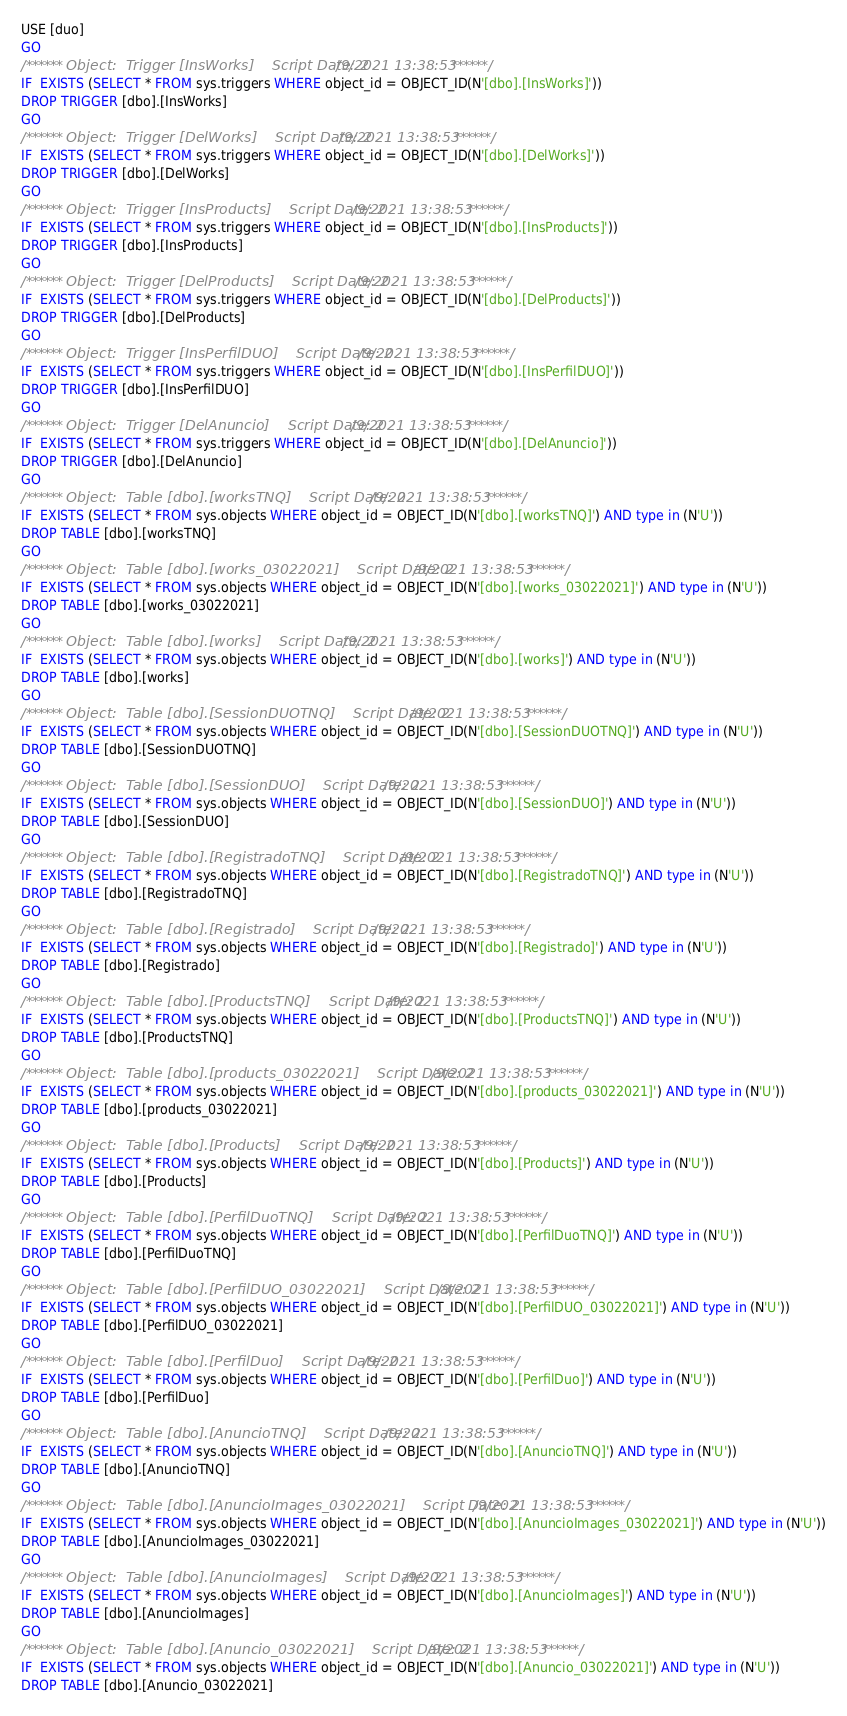Convert code to text. <code><loc_0><loc_0><loc_500><loc_500><_SQL_>USE [duo]
GO
/****** Object:  Trigger [InsWorks]    Script Date: 2/9/2021 13:38:53 ******/
IF  EXISTS (SELECT * FROM sys.triggers WHERE object_id = OBJECT_ID(N'[dbo].[InsWorks]'))
DROP TRIGGER [dbo].[InsWorks]
GO
/****** Object:  Trigger [DelWorks]    Script Date: 2/9/2021 13:38:53 ******/
IF  EXISTS (SELECT * FROM sys.triggers WHERE object_id = OBJECT_ID(N'[dbo].[DelWorks]'))
DROP TRIGGER [dbo].[DelWorks]
GO
/****** Object:  Trigger [InsProducts]    Script Date: 2/9/2021 13:38:53 ******/
IF  EXISTS (SELECT * FROM sys.triggers WHERE object_id = OBJECT_ID(N'[dbo].[InsProducts]'))
DROP TRIGGER [dbo].[InsProducts]
GO
/****** Object:  Trigger [DelProducts]    Script Date: 2/9/2021 13:38:53 ******/
IF  EXISTS (SELECT * FROM sys.triggers WHERE object_id = OBJECT_ID(N'[dbo].[DelProducts]'))
DROP TRIGGER [dbo].[DelProducts]
GO
/****** Object:  Trigger [InsPerfilDUO]    Script Date: 2/9/2021 13:38:53 ******/
IF  EXISTS (SELECT * FROM sys.triggers WHERE object_id = OBJECT_ID(N'[dbo].[InsPerfilDUO]'))
DROP TRIGGER [dbo].[InsPerfilDUO]
GO
/****** Object:  Trigger [DelAnuncio]    Script Date: 2/9/2021 13:38:53 ******/
IF  EXISTS (SELECT * FROM sys.triggers WHERE object_id = OBJECT_ID(N'[dbo].[DelAnuncio]'))
DROP TRIGGER [dbo].[DelAnuncio]
GO
/****** Object:  Table [dbo].[worksTNQ]    Script Date: 2/9/2021 13:38:53 ******/
IF  EXISTS (SELECT * FROM sys.objects WHERE object_id = OBJECT_ID(N'[dbo].[worksTNQ]') AND type in (N'U'))
DROP TABLE [dbo].[worksTNQ]
GO
/****** Object:  Table [dbo].[works_03022021]    Script Date: 2/9/2021 13:38:53 ******/
IF  EXISTS (SELECT * FROM sys.objects WHERE object_id = OBJECT_ID(N'[dbo].[works_03022021]') AND type in (N'U'))
DROP TABLE [dbo].[works_03022021]
GO
/****** Object:  Table [dbo].[works]    Script Date: 2/9/2021 13:38:53 ******/
IF  EXISTS (SELECT * FROM sys.objects WHERE object_id = OBJECT_ID(N'[dbo].[works]') AND type in (N'U'))
DROP TABLE [dbo].[works]
GO
/****** Object:  Table [dbo].[SessionDUOTNQ]    Script Date: 2/9/2021 13:38:53 ******/
IF  EXISTS (SELECT * FROM sys.objects WHERE object_id = OBJECT_ID(N'[dbo].[SessionDUOTNQ]') AND type in (N'U'))
DROP TABLE [dbo].[SessionDUOTNQ]
GO
/****** Object:  Table [dbo].[SessionDUO]    Script Date: 2/9/2021 13:38:53 ******/
IF  EXISTS (SELECT * FROM sys.objects WHERE object_id = OBJECT_ID(N'[dbo].[SessionDUO]') AND type in (N'U'))
DROP TABLE [dbo].[SessionDUO]
GO
/****** Object:  Table [dbo].[RegistradoTNQ]    Script Date: 2/9/2021 13:38:53 ******/
IF  EXISTS (SELECT * FROM sys.objects WHERE object_id = OBJECT_ID(N'[dbo].[RegistradoTNQ]') AND type in (N'U'))
DROP TABLE [dbo].[RegistradoTNQ]
GO
/****** Object:  Table [dbo].[Registrado]    Script Date: 2/9/2021 13:38:53 ******/
IF  EXISTS (SELECT * FROM sys.objects WHERE object_id = OBJECT_ID(N'[dbo].[Registrado]') AND type in (N'U'))
DROP TABLE [dbo].[Registrado]
GO
/****** Object:  Table [dbo].[ProductsTNQ]    Script Date: 2/9/2021 13:38:53 ******/
IF  EXISTS (SELECT * FROM sys.objects WHERE object_id = OBJECT_ID(N'[dbo].[ProductsTNQ]') AND type in (N'U'))
DROP TABLE [dbo].[ProductsTNQ]
GO
/****** Object:  Table [dbo].[products_03022021]    Script Date: 2/9/2021 13:38:53 ******/
IF  EXISTS (SELECT * FROM sys.objects WHERE object_id = OBJECT_ID(N'[dbo].[products_03022021]') AND type in (N'U'))
DROP TABLE [dbo].[products_03022021]
GO
/****** Object:  Table [dbo].[Products]    Script Date: 2/9/2021 13:38:53 ******/
IF  EXISTS (SELECT * FROM sys.objects WHERE object_id = OBJECT_ID(N'[dbo].[Products]') AND type in (N'U'))
DROP TABLE [dbo].[Products]
GO
/****** Object:  Table [dbo].[PerfilDuoTNQ]    Script Date: 2/9/2021 13:38:53 ******/
IF  EXISTS (SELECT * FROM sys.objects WHERE object_id = OBJECT_ID(N'[dbo].[PerfilDuoTNQ]') AND type in (N'U'))
DROP TABLE [dbo].[PerfilDuoTNQ]
GO
/****** Object:  Table [dbo].[PerfilDUO_03022021]    Script Date: 2/9/2021 13:38:53 ******/
IF  EXISTS (SELECT * FROM sys.objects WHERE object_id = OBJECT_ID(N'[dbo].[PerfilDUO_03022021]') AND type in (N'U'))
DROP TABLE [dbo].[PerfilDUO_03022021]
GO
/****** Object:  Table [dbo].[PerfilDuo]    Script Date: 2/9/2021 13:38:53 ******/
IF  EXISTS (SELECT * FROM sys.objects WHERE object_id = OBJECT_ID(N'[dbo].[PerfilDuo]') AND type in (N'U'))
DROP TABLE [dbo].[PerfilDuo]
GO
/****** Object:  Table [dbo].[AnuncioTNQ]    Script Date: 2/9/2021 13:38:53 ******/
IF  EXISTS (SELECT * FROM sys.objects WHERE object_id = OBJECT_ID(N'[dbo].[AnuncioTNQ]') AND type in (N'U'))
DROP TABLE [dbo].[AnuncioTNQ]
GO
/****** Object:  Table [dbo].[AnuncioImages_03022021]    Script Date: 2/9/2021 13:38:53 ******/
IF  EXISTS (SELECT * FROM sys.objects WHERE object_id = OBJECT_ID(N'[dbo].[AnuncioImages_03022021]') AND type in (N'U'))
DROP TABLE [dbo].[AnuncioImages_03022021]
GO
/****** Object:  Table [dbo].[AnuncioImages]    Script Date: 2/9/2021 13:38:53 ******/
IF  EXISTS (SELECT * FROM sys.objects WHERE object_id = OBJECT_ID(N'[dbo].[AnuncioImages]') AND type in (N'U'))
DROP TABLE [dbo].[AnuncioImages]
GO
/****** Object:  Table [dbo].[Anuncio_03022021]    Script Date: 2/9/2021 13:38:53 ******/
IF  EXISTS (SELECT * FROM sys.objects WHERE object_id = OBJECT_ID(N'[dbo].[Anuncio_03022021]') AND type in (N'U'))
DROP TABLE [dbo].[Anuncio_03022021]</code> 